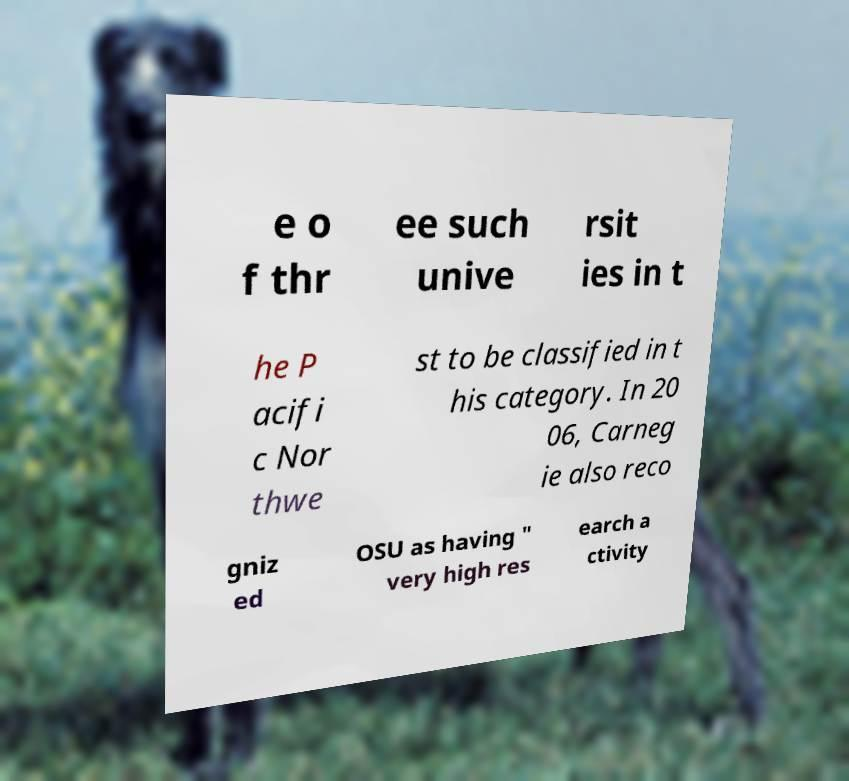Please read and relay the text visible in this image. What does it say? e o f thr ee such unive rsit ies in t he P acifi c Nor thwe st to be classified in t his category. In 20 06, Carneg ie also reco gniz ed OSU as having " very high res earch a ctivity 